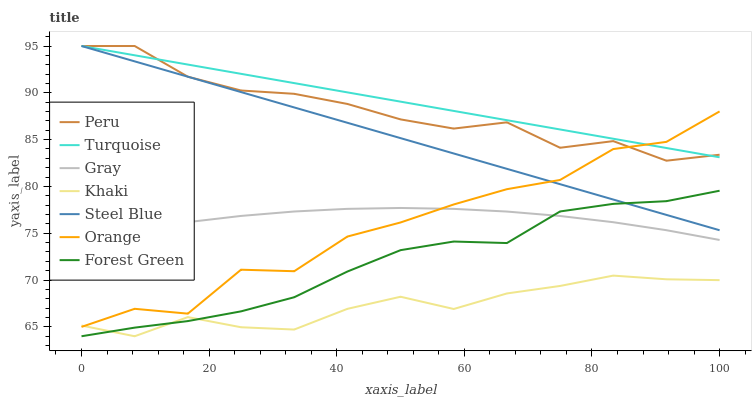Does Khaki have the minimum area under the curve?
Answer yes or no. Yes. Does Turquoise have the maximum area under the curve?
Answer yes or no. Yes. Does Turquoise have the minimum area under the curve?
Answer yes or no. No. Does Khaki have the maximum area under the curve?
Answer yes or no. No. Is Turquoise the smoothest?
Answer yes or no. Yes. Is Orange the roughest?
Answer yes or no. Yes. Is Khaki the smoothest?
Answer yes or no. No. Is Khaki the roughest?
Answer yes or no. No. Does Turquoise have the lowest value?
Answer yes or no. No. Does Khaki have the highest value?
Answer yes or no. No. Is Forest Green less than Peru?
Answer yes or no. Yes. Is Peru greater than Gray?
Answer yes or no. Yes. Does Forest Green intersect Peru?
Answer yes or no. No. 